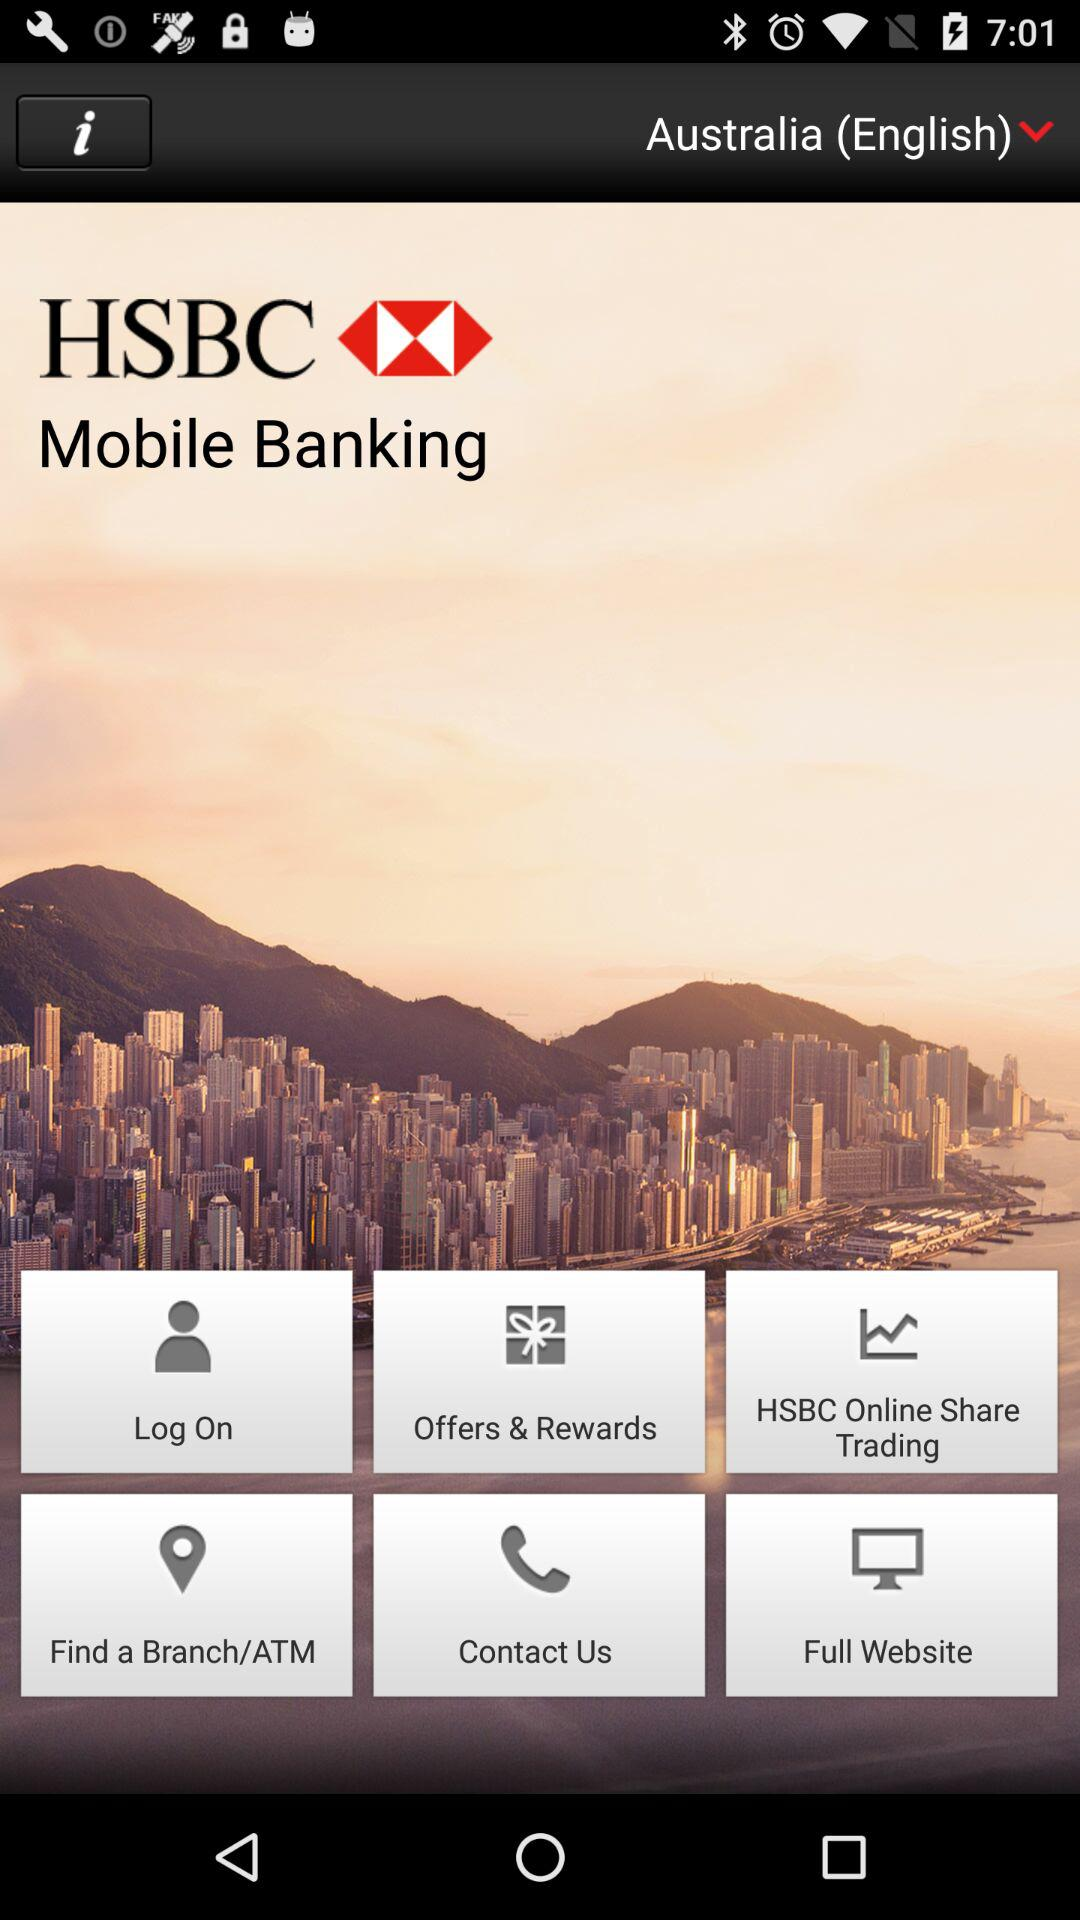What is the name of the application? The name of the application is "HSBC". 